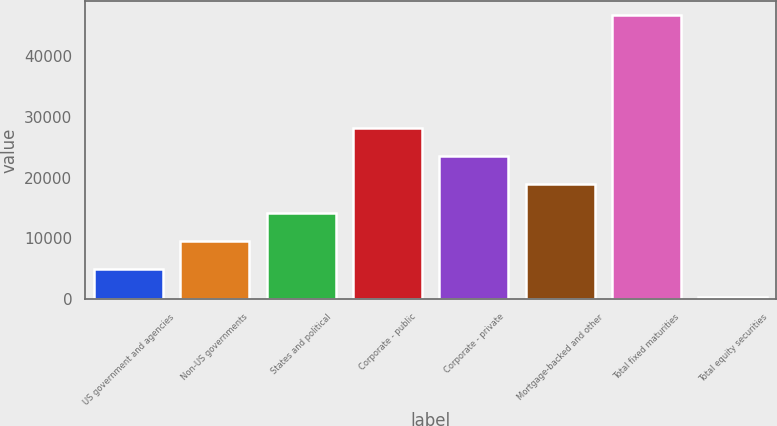<chart> <loc_0><loc_0><loc_500><loc_500><bar_chart><fcel>US government and agencies<fcel>Non-US governments<fcel>States and political<fcel>Corporate - public<fcel>Corporate - private<fcel>Mortgage-backed and other<fcel>Total fixed maturities<fcel>Total equity securities<nl><fcel>4958.65<fcel>9600.9<fcel>14243.1<fcel>28169.9<fcel>23527.7<fcel>18885.4<fcel>46738.9<fcel>316.4<nl></chart> 